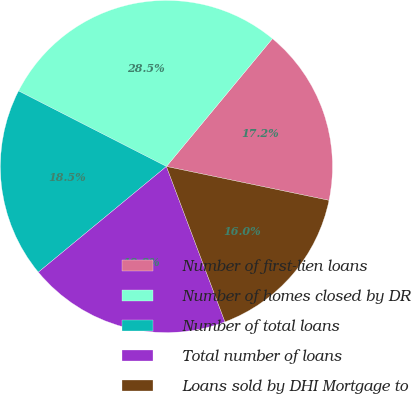Convert chart. <chart><loc_0><loc_0><loc_500><loc_500><pie_chart><fcel>Number of first-lien loans<fcel>Number of homes closed by DR<fcel>Number of total loans<fcel>Total number of loans<fcel>Loans sold by DHI Mortgage to<nl><fcel>17.25%<fcel>28.5%<fcel>18.5%<fcel>19.75%<fcel>16.0%<nl></chart> 